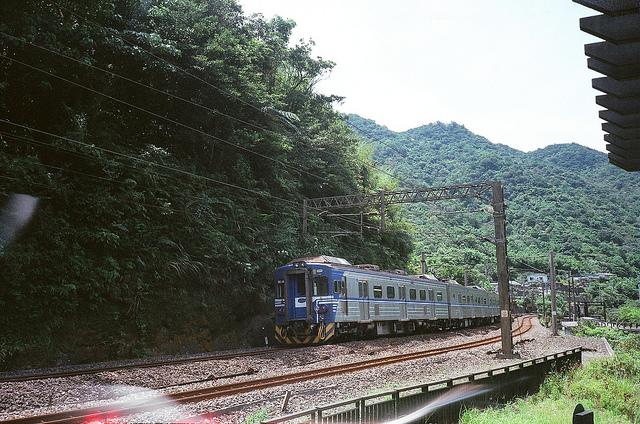Where is the train going?
Write a very short answer. To station. How many tracks can be seen?
Keep it brief. 2. Is the train on a bridge?
Keep it brief. No. Is the train crossing over a busy highway?
Short answer required. No. 